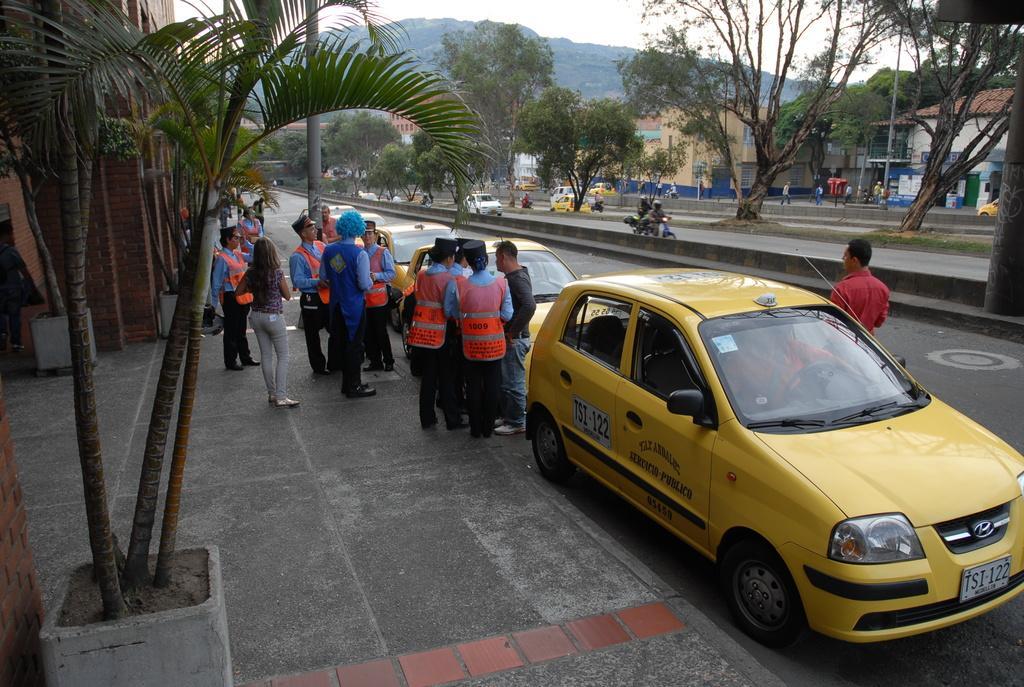Please provide a concise description of this image. In this image there is a road on which there are yellow cars parked on the road. On the footpath there are few security officers who are talking with the people. On the left side there are plants and buildings. On the right side there are trees. On the road there are some vehicles. At the top there is the sky. In the background there are hills. 